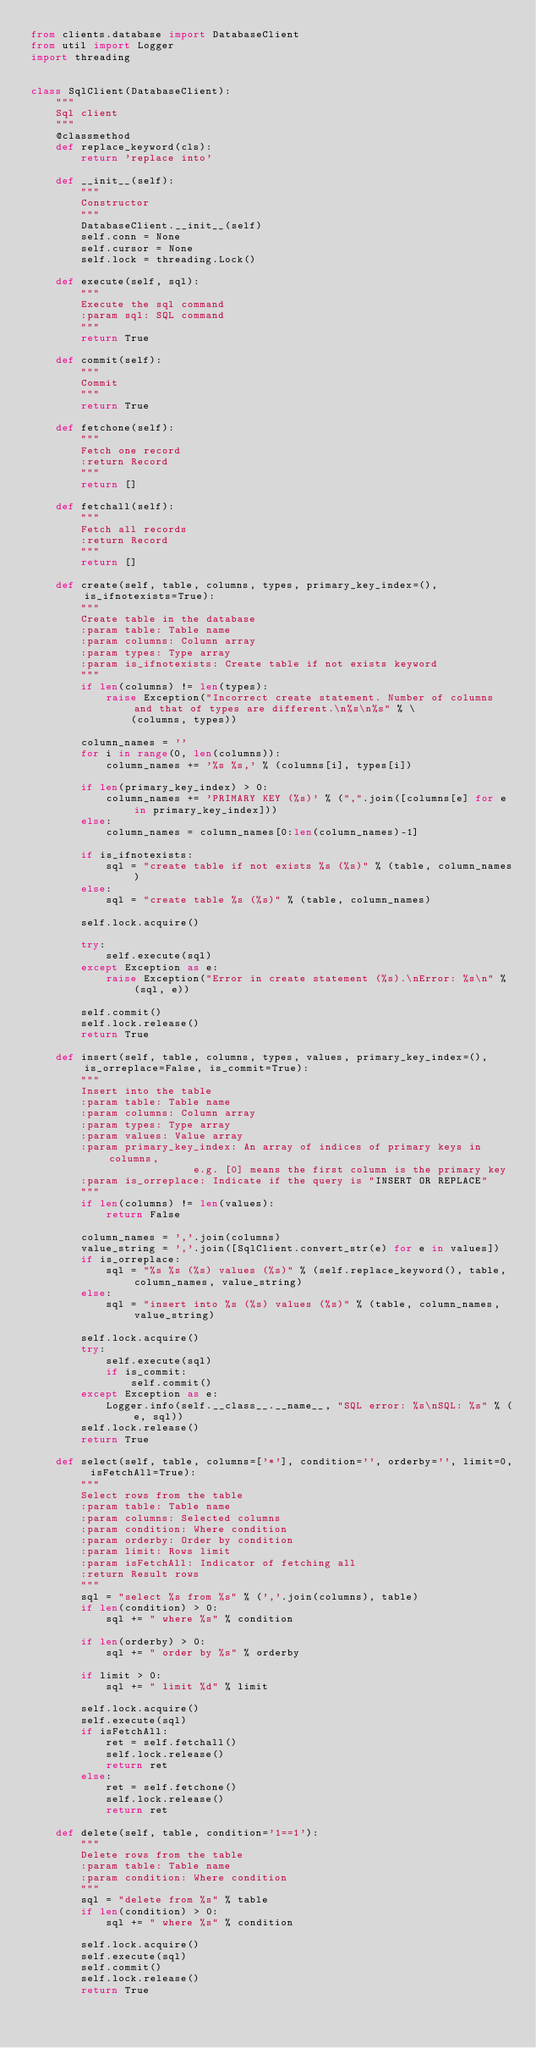<code> <loc_0><loc_0><loc_500><loc_500><_Python_>from clients.database import DatabaseClient
from util import Logger
import threading


class SqlClient(DatabaseClient):
    """
    Sql client
    """
    @classmethod
    def replace_keyword(cls):
        return 'replace into'

    def __init__(self):
        """
        Constructor
        """
        DatabaseClient.__init__(self)
        self.conn = None
        self.cursor = None
        self.lock = threading.Lock()

    def execute(self, sql):
        """
        Execute the sql command
        :param sql: SQL command
        """
        return True

    def commit(self):
        """
        Commit
        """
        return True

    def fetchone(self):
        """
        Fetch one record
        :return Record
        """
        return []

    def fetchall(self):
        """
        Fetch all records
        :return Record
        """
        return []

    def create(self, table, columns, types, primary_key_index=(), is_ifnotexists=True):
        """
        Create table in the database
        :param table: Table name
        :param columns: Column array
        :param types: Type array
        :param is_ifnotexists: Create table if not exists keyword
        """
        if len(columns) != len(types):
            raise Exception("Incorrect create statement. Number of columns and that of types are different.\n%s\n%s" % \
                (columns, types))

        column_names = ''
        for i in range(0, len(columns)):
            column_names += '%s %s,' % (columns[i], types[i])

        if len(primary_key_index) > 0:
            column_names += 'PRIMARY KEY (%s)' % (",".join([columns[e] for e in primary_key_index]))
        else:
            column_names = column_names[0:len(column_names)-1]

        if is_ifnotexists:
            sql = "create table if not exists %s (%s)" % (table, column_names)
        else:
            sql = "create table %s (%s)" % (table, column_names)

        self.lock.acquire()

        try:
            self.execute(sql)
        except Exception as e:
            raise Exception("Error in create statement (%s).\nError: %s\n" % (sql, e))

        self.commit()
        self.lock.release()
        return True

    def insert(self, table, columns, types, values, primary_key_index=(), is_orreplace=False, is_commit=True):
        """
        Insert into the table
        :param table: Table name
        :param columns: Column array
        :param types: Type array
        :param values: Value array
        :param primary_key_index: An array of indices of primary keys in columns,
                          e.g. [0] means the first column is the primary key
        :param is_orreplace: Indicate if the query is "INSERT OR REPLACE"
        """
        if len(columns) != len(values):
            return False

        column_names = ','.join(columns)
        value_string = ','.join([SqlClient.convert_str(e) for e in values])
        if is_orreplace:
            sql = "%s %s (%s) values (%s)" % (self.replace_keyword(), table, column_names, value_string)
        else:
            sql = "insert into %s (%s) values (%s)" % (table, column_names, value_string)

        self.lock.acquire()
        try:
            self.execute(sql)
            if is_commit:
                self.commit()
        except Exception as e:
            Logger.info(self.__class__.__name__, "SQL error: %s\nSQL: %s" % (e, sql))
        self.lock.release()
        return True

    def select(self, table, columns=['*'], condition='', orderby='', limit=0, isFetchAll=True):
        """
        Select rows from the table
        :param table: Table name
        :param columns: Selected columns
        :param condition: Where condition
        :param orderby: Order by condition
        :param limit: Rows limit
        :param isFetchAll: Indicator of fetching all
        :return Result rows
        """
        sql = "select %s from %s" % (','.join(columns), table)
        if len(condition) > 0:
            sql += " where %s" % condition

        if len(orderby) > 0:
            sql += " order by %s" % orderby

        if limit > 0:
            sql += " limit %d" % limit

        self.lock.acquire()
        self.execute(sql)
        if isFetchAll:
            ret = self.fetchall()
            self.lock.release()
            return ret
        else:
            ret = self.fetchone()
            self.lock.release()
            return ret

    def delete(self, table, condition='1==1'):
        """
        Delete rows from the table
        :param table: Table name
        :param condition: Where condition
        """
        sql = "delete from %s" % table
        if len(condition) > 0:
            sql += " where %s" % condition

        self.lock.acquire()
        self.execute(sql)
        self.commit()
        self.lock.release()
        return True
</code> 